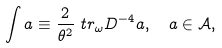Convert formula to latex. <formula><loc_0><loc_0><loc_500><loc_500>& \int a \equiv \frac { 2 } { \theta ^ { 2 } } \ t r _ { \omega } D ^ { - 4 } a , \quad a \in \mathcal { A } ,</formula> 